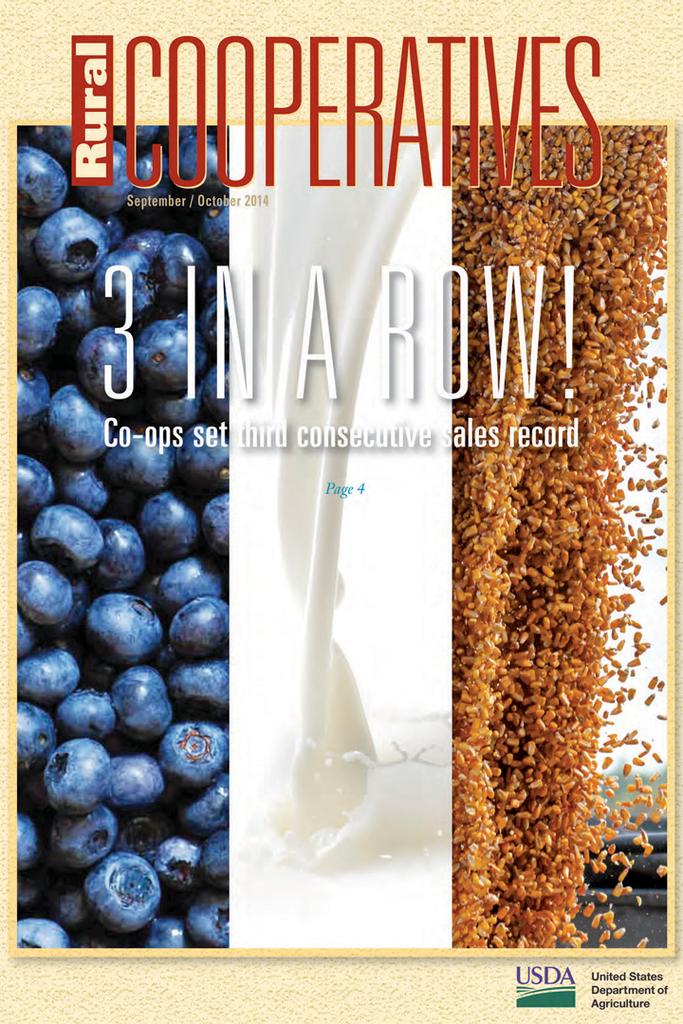Who set three consecutive sales records?
Your response must be concise. Co-ops. 3 in a what?
Your response must be concise. Row. 